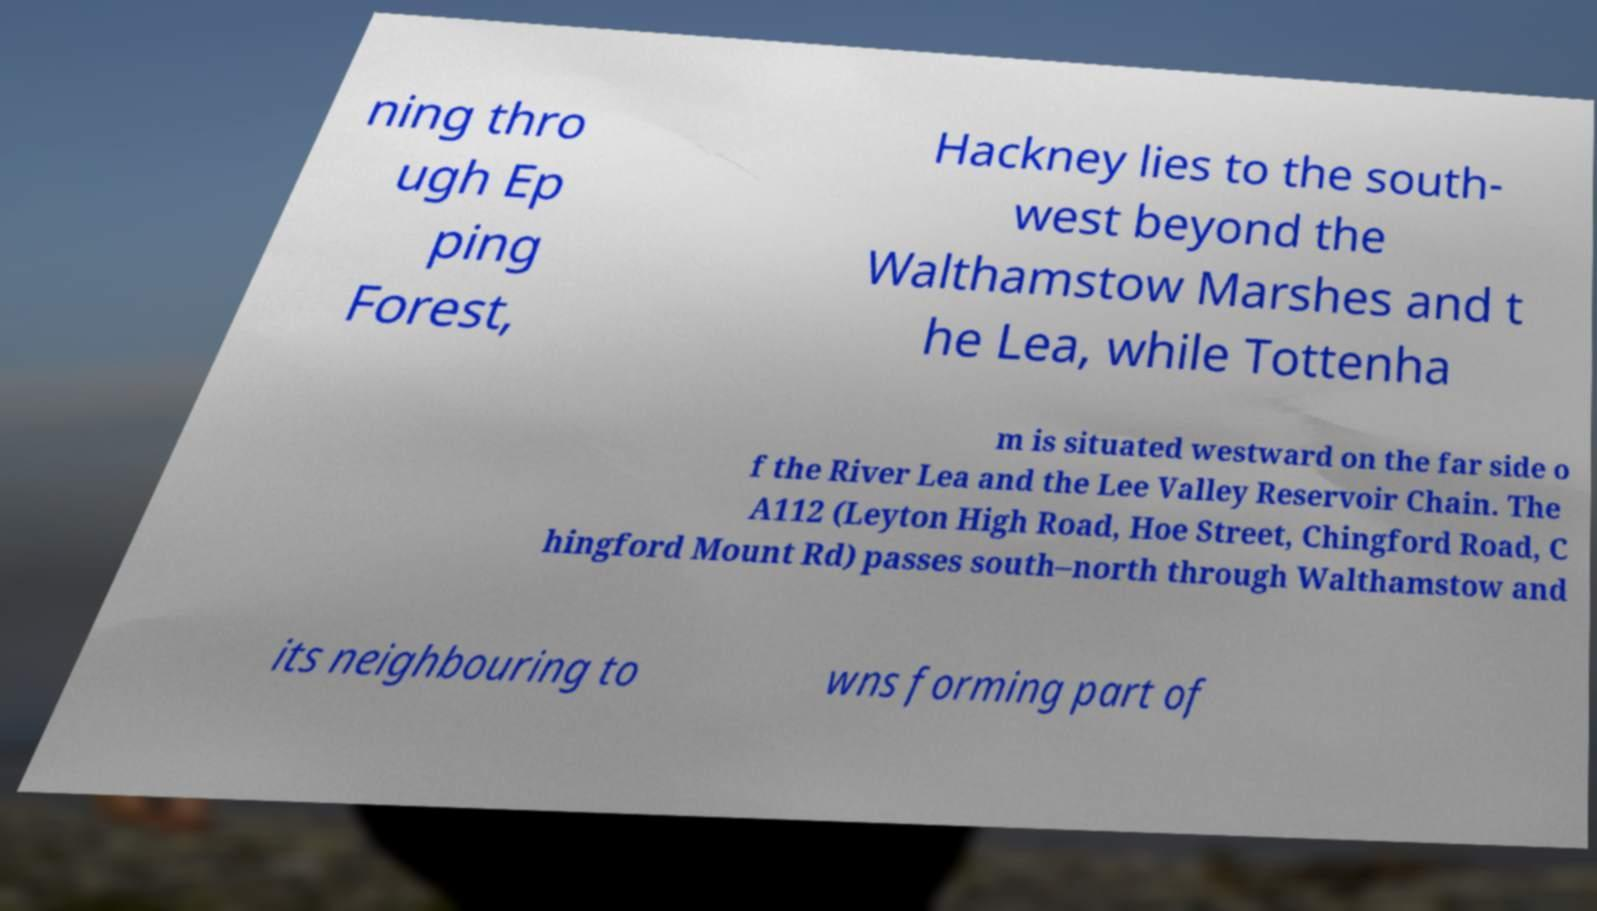Could you extract and type out the text from this image? ning thro ugh Ep ping Forest, Hackney lies to the south- west beyond the Walthamstow Marshes and t he Lea, while Tottenha m is situated westward on the far side o f the River Lea and the Lee Valley Reservoir Chain. The A112 (Leyton High Road, Hoe Street, Chingford Road, C hingford Mount Rd) passes south–north through Walthamstow and its neighbouring to wns forming part of 